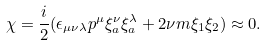<formula> <loc_0><loc_0><loc_500><loc_500>\chi = \frac { i } { 2 } ( \epsilon _ { \mu \nu \lambda } p ^ { \mu } \xi _ { a } ^ { \nu } \xi _ { a } ^ { \lambda } + 2 \nu m \xi _ { 1 } \xi _ { 2 } ) \approx 0 .</formula> 